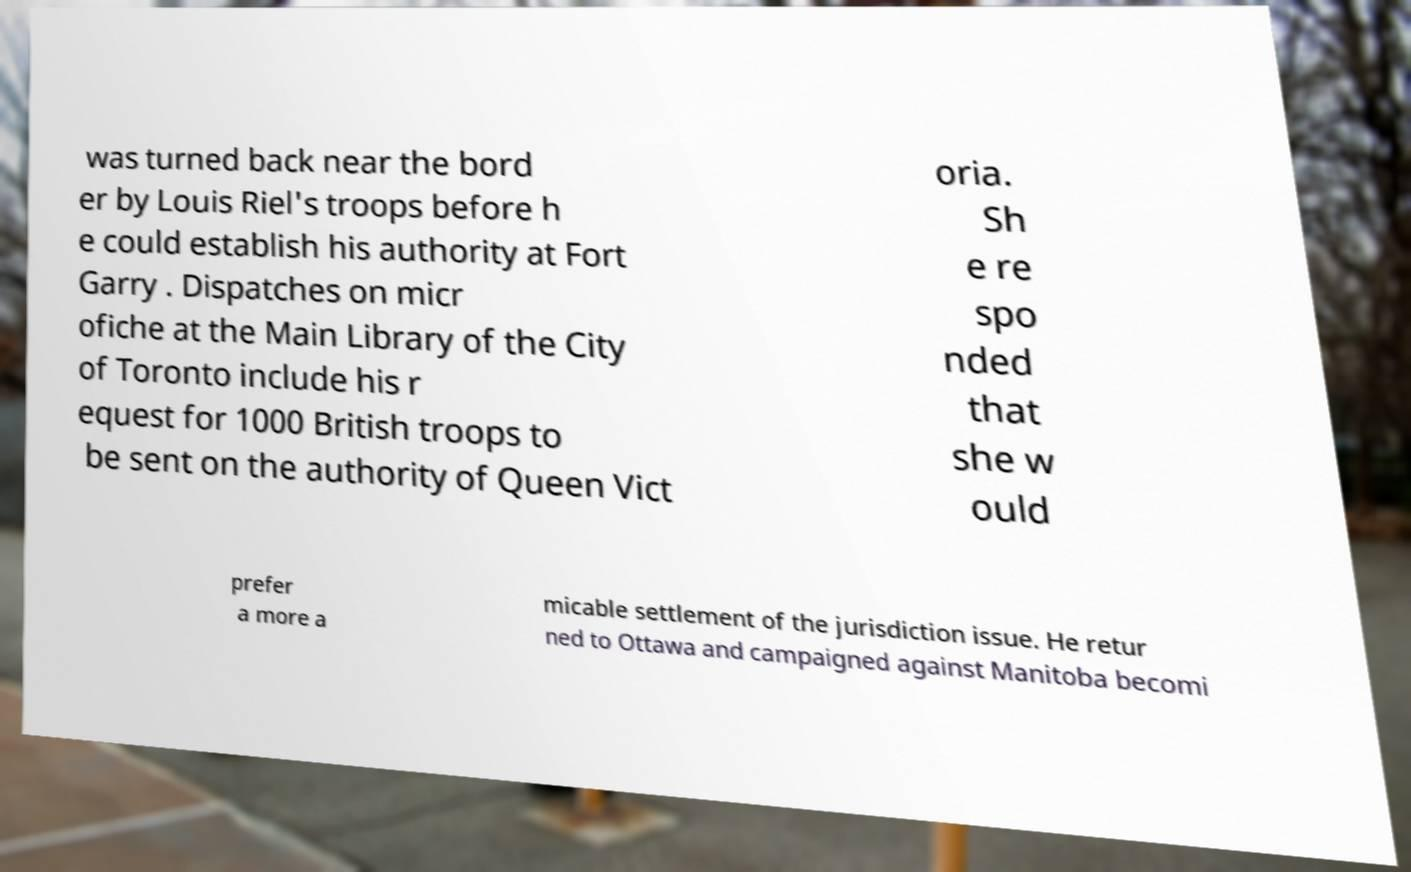Can you read and provide the text displayed in the image?This photo seems to have some interesting text. Can you extract and type it out for me? was turned back near the bord er by Louis Riel's troops before h e could establish his authority at Fort Garry . Dispatches on micr ofiche at the Main Library of the City of Toronto include his r equest for 1000 British troops to be sent on the authority of Queen Vict oria. Sh e re spo nded that she w ould prefer a more a micable settlement of the jurisdiction issue. He retur ned to Ottawa and campaigned against Manitoba becomi 